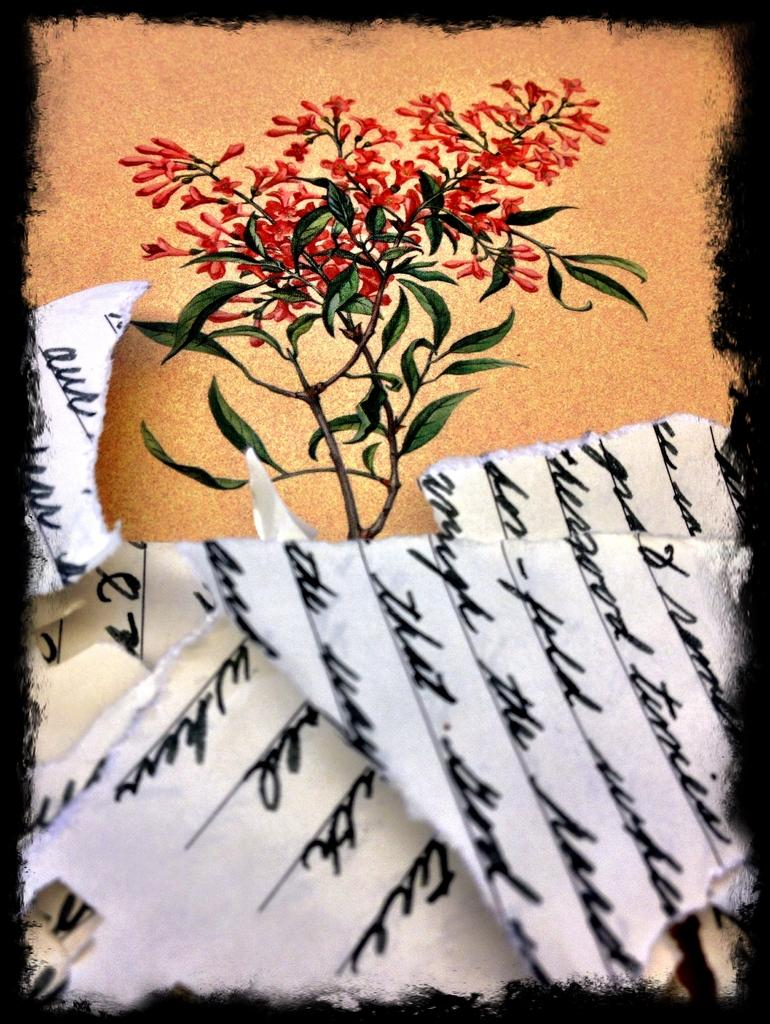What is present on the paper in the image? The facts do not specify any details about the paper in the image. What type of artwork is depicted in the image? There is a painting of a flower plant in the image. What type of honey is being used to paint the flower plant in the image? There is no mention of honey being used in the image; it is a painting of a flower plant. What condition is the mitten in, as seen in the image? There is no mitten present in the image. 